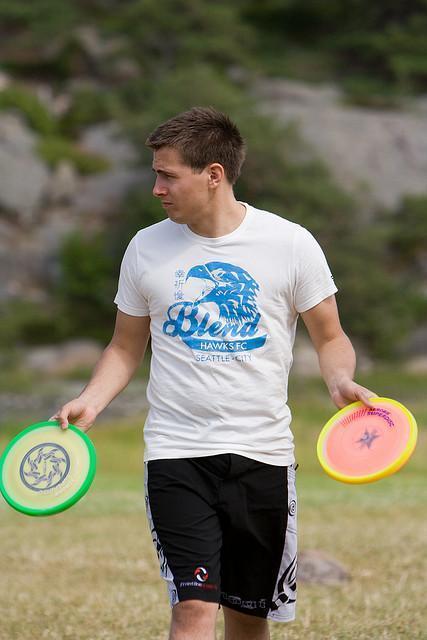How many frisbees is he holding?
Give a very brief answer. 2. How many frisbees are in the picture?
Give a very brief answer. 2. 